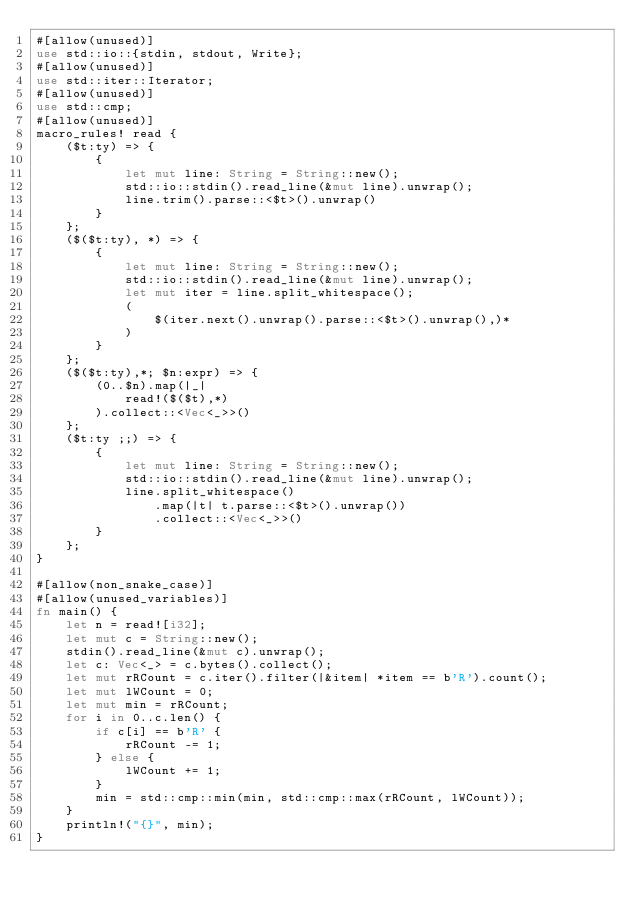Convert code to text. <code><loc_0><loc_0><loc_500><loc_500><_Rust_>#[allow(unused)]
use std::io::{stdin, stdout, Write};
#[allow(unused)]
use std::iter::Iterator;
#[allow(unused)]
use std::cmp;
#[allow(unused)]
macro_rules! read {
    ($t:ty) => {
        {
            let mut line: String = String::new();
            std::io::stdin().read_line(&mut line).unwrap();
            line.trim().parse::<$t>().unwrap()
        }
    };
    ($($t:ty), *) => {
        {
            let mut line: String = String::new();
            std::io::stdin().read_line(&mut line).unwrap();
            let mut iter = line.split_whitespace();
            (
                $(iter.next().unwrap().parse::<$t>().unwrap(),)*
            )
        }
    };
    ($($t:ty),*; $n:expr) => {
        (0..$n).map(|_|
            read!($($t),*)
        ).collect::<Vec<_>>()
    };
    ($t:ty ;;) => {
        {
            let mut line: String = String::new();
            std::io::stdin().read_line(&mut line).unwrap();
            line.split_whitespace()
                .map(|t| t.parse::<$t>().unwrap())
                .collect::<Vec<_>>()
        }
    };
}

#[allow(non_snake_case)]
#[allow(unused_variables)]
fn main() {
    let n = read![i32];
    let mut c = String::new();
    stdin().read_line(&mut c).unwrap();
    let c: Vec<_> = c.bytes().collect();
    let mut rRCount = c.iter().filter(|&item| *item == b'R').count();
    let mut lWCount = 0;
    let mut min = rRCount;
    for i in 0..c.len() {
        if c[i] == b'R' {
            rRCount -= 1;
        } else {
            lWCount += 1;
        }
        min = std::cmp::min(min, std::cmp::max(rRCount, lWCount));
    }
    println!("{}", min);
}</code> 